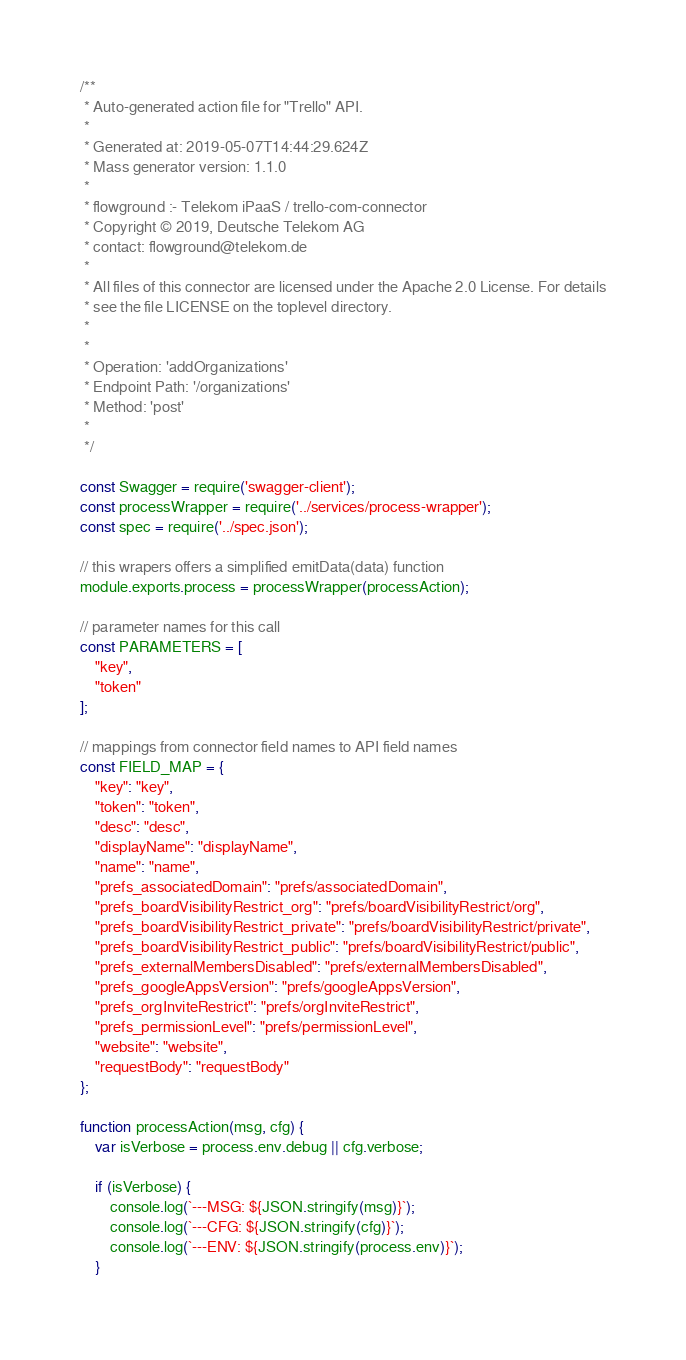<code> <loc_0><loc_0><loc_500><loc_500><_JavaScript_>/**
 * Auto-generated action file for "Trello" API.
 *
 * Generated at: 2019-05-07T14:44:29.624Z
 * Mass generator version: 1.1.0
 *
 * flowground :- Telekom iPaaS / trello-com-connector
 * Copyright © 2019, Deutsche Telekom AG
 * contact: flowground@telekom.de
 *
 * All files of this connector are licensed under the Apache 2.0 License. For details
 * see the file LICENSE on the toplevel directory.
 *
 *
 * Operation: 'addOrganizations'
 * Endpoint Path: '/organizations'
 * Method: 'post'
 *
 */

const Swagger = require('swagger-client');
const processWrapper = require('../services/process-wrapper');
const spec = require('../spec.json');

// this wrapers offers a simplified emitData(data) function
module.exports.process = processWrapper(processAction);

// parameter names for this call
const PARAMETERS = [
    "key",
    "token"
];

// mappings from connector field names to API field names
const FIELD_MAP = {
    "key": "key",
    "token": "token",
    "desc": "desc",
    "displayName": "displayName",
    "name": "name",
    "prefs_associatedDomain": "prefs/associatedDomain",
    "prefs_boardVisibilityRestrict_org": "prefs/boardVisibilityRestrict/org",
    "prefs_boardVisibilityRestrict_private": "prefs/boardVisibilityRestrict/private",
    "prefs_boardVisibilityRestrict_public": "prefs/boardVisibilityRestrict/public",
    "prefs_externalMembersDisabled": "prefs/externalMembersDisabled",
    "prefs_googleAppsVersion": "prefs/googleAppsVersion",
    "prefs_orgInviteRestrict": "prefs/orgInviteRestrict",
    "prefs_permissionLevel": "prefs/permissionLevel",
    "website": "website",
    "requestBody": "requestBody"
};

function processAction(msg, cfg) {
    var isVerbose = process.env.debug || cfg.verbose;

    if (isVerbose) {
        console.log(`---MSG: ${JSON.stringify(msg)}`);
        console.log(`---CFG: ${JSON.stringify(cfg)}`);
        console.log(`---ENV: ${JSON.stringify(process.env)}`);
    }
</code> 